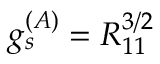Convert formula to latex. <formula><loc_0><loc_0><loc_500><loc_500>g _ { s } ^ { ( A ) } = R _ { 1 1 } ^ { 3 / 2 }</formula> 